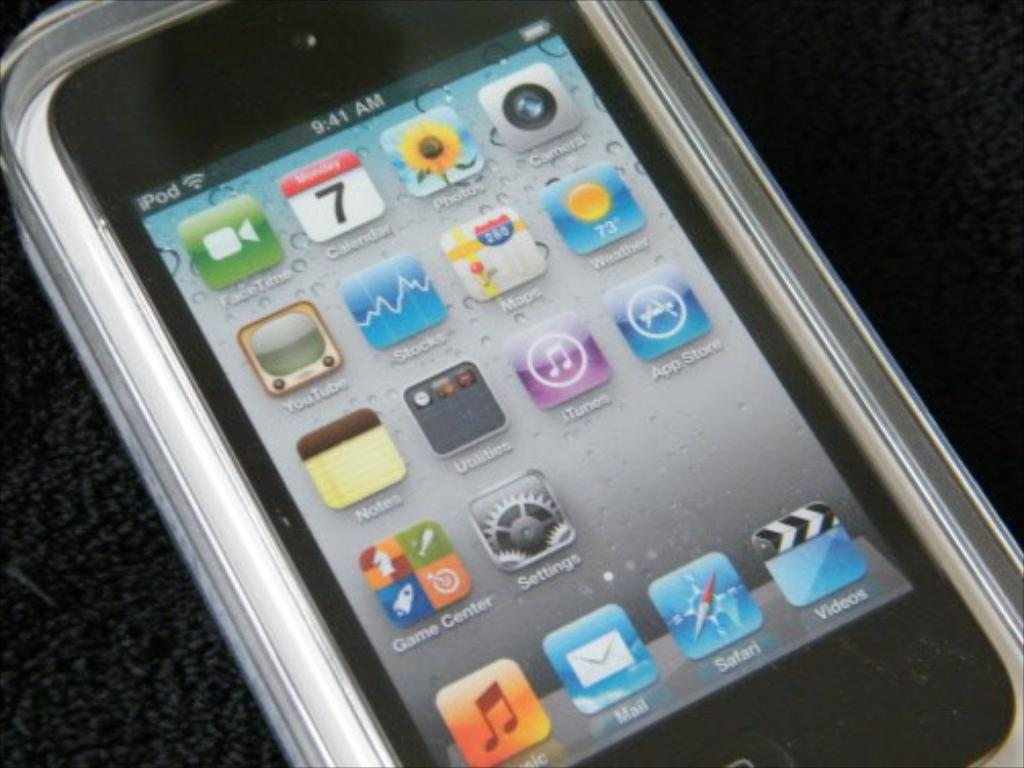<image>
Describe the image concisely. A digital screen that says iPod 9:41 AM 